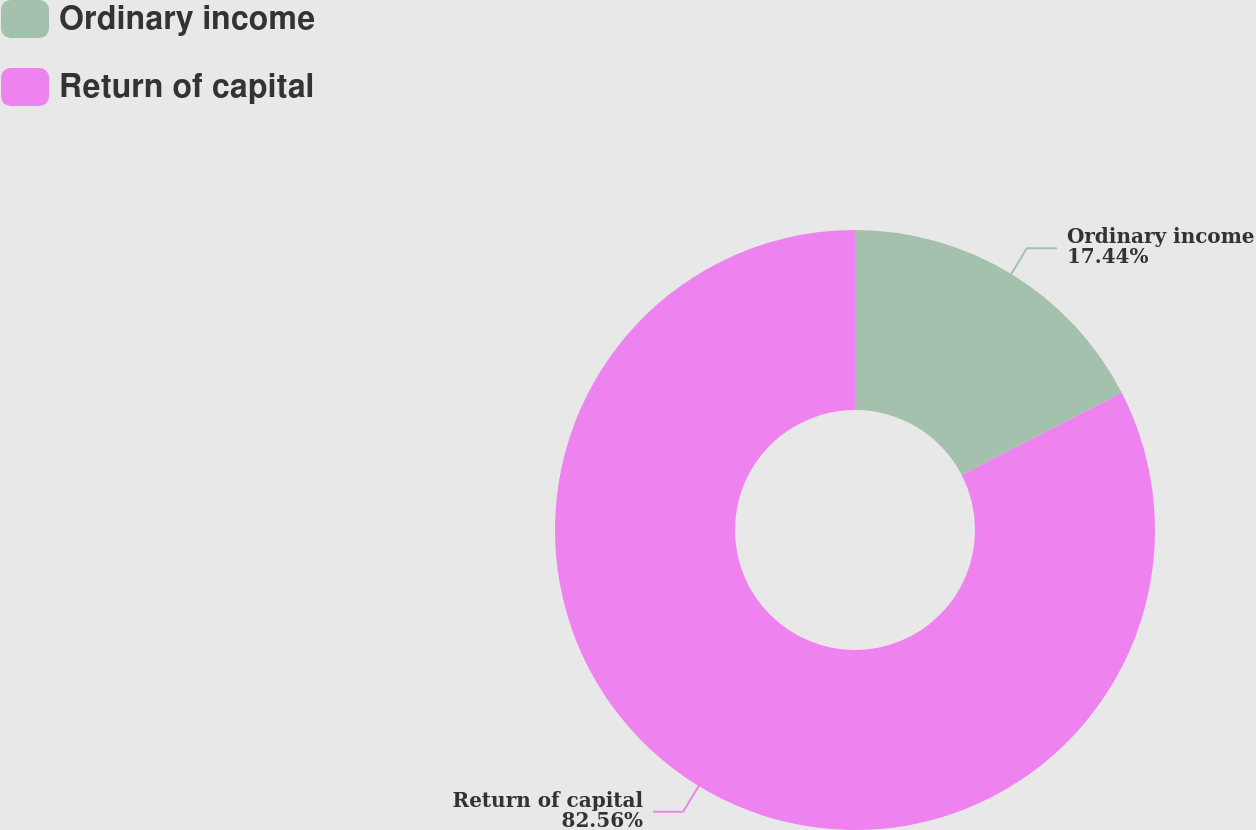<chart> <loc_0><loc_0><loc_500><loc_500><pie_chart><fcel>Ordinary income<fcel>Return of capital<nl><fcel>17.44%<fcel>82.56%<nl></chart> 